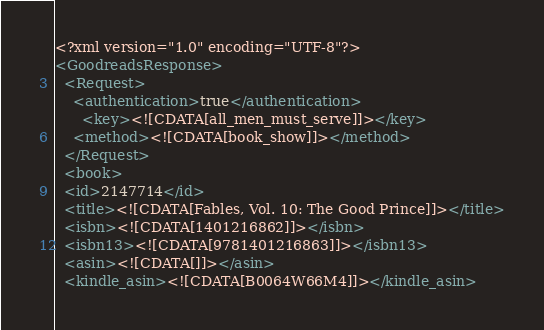Convert code to text. <code><loc_0><loc_0><loc_500><loc_500><_XML_><?xml version="1.0" encoding="UTF-8"?>
<GoodreadsResponse>
  <Request>
    <authentication>true</authentication>
      <key><![CDATA[all_men_must_serve]]></key>
    <method><![CDATA[book_show]]></method>
  </Request>
  <book>
  <id>2147714</id>
  <title><![CDATA[Fables, Vol. 10: The Good Prince]]></title>
  <isbn><![CDATA[1401216862]]></isbn>
  <isbn13><![CDATA[9781401216863]]></isbn13>
  <asin><![CDATA[]]></asin>
  <kindle_asin><![CDATA[B0064W66M4]]></kindle_asin></code> 